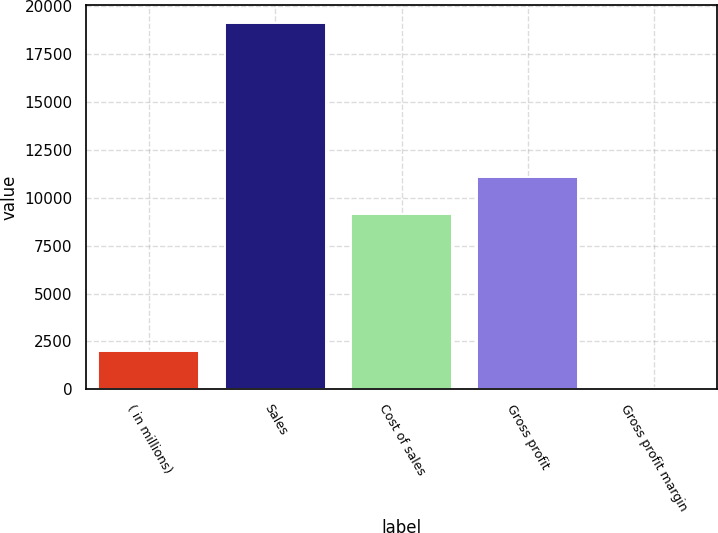<chart> <loc_0><loc_0><loc_500><loc_500><bar_chart><fcel>( in millions)<fcel>Sales<fcel>Cost of sales<fcel>Gross profit<fcel>Gross profit margin<nl><fcel>2013<fcel>19118<fcel>9160.4<fcel>11067<fcel>52.1<nl></chart> 